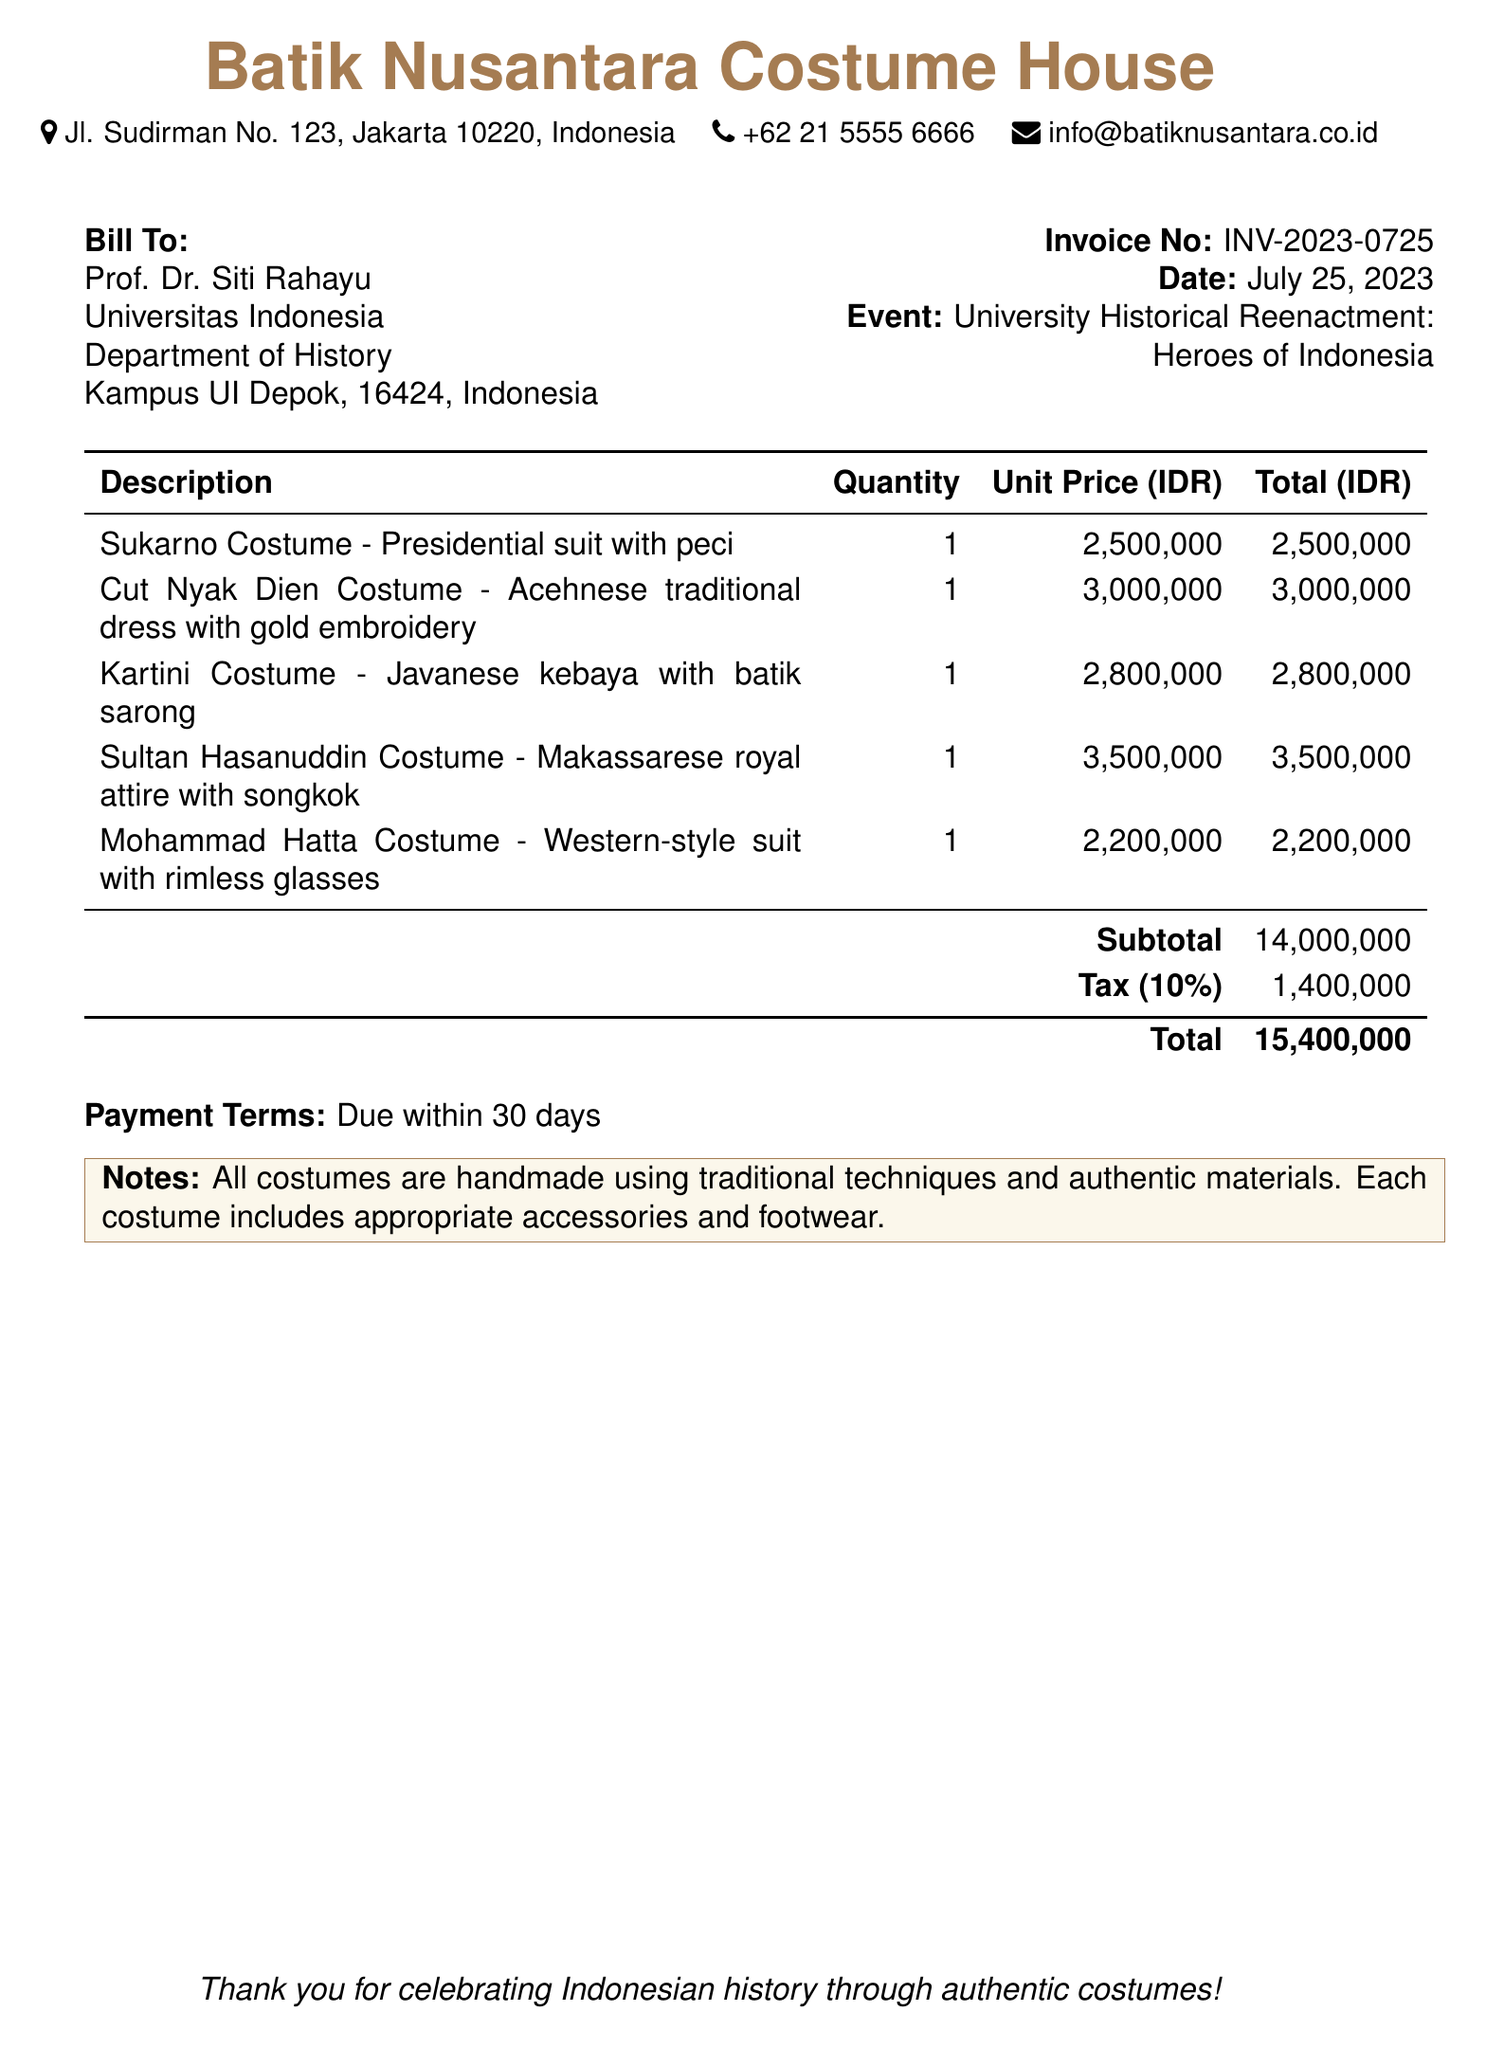What is the invoice number? The invoice number is listed clearly in the document as INV-2023-0725.
Answer: INV-2023-0725 Who is billed for the costumes? The document specifies that Prof. Dr. Siti Rahayu is the recipient of the bill.
Answer: Prof. Dr. Siti Rahayu What is the total amount due? The total amount is calculated at the bottom of the bill and is stated as IDR 15,400,000.
Answer: 15,400,000 How many different costumes are listed in the document? By counting the descriptions in the table, there are five different costumes listed.
Answer: 5 What is the unit price of the Cut Nyak Dien Costume? The unit price for the Cut Nyak Dien Costume is given as IDR 3,000,000.
Answer: 3,000,000 What is the tax percentage applied to the subtotal? The document states that the tax applied is 10%.
Answer: 10% What does the payment terms state? The payment terms noted in the document indicate that payment is due within 30 days.
Answer: Due within 30 days What type of costumes does the bill describe? The document describes traditional Indonesian costumes handmade with authentic materials.
Answer: Traditional Indonesian costumes What is included with each costume? The notes section specifies that each costume includes appropriate accessories and footwear.
Answer: Accessories and footwear 